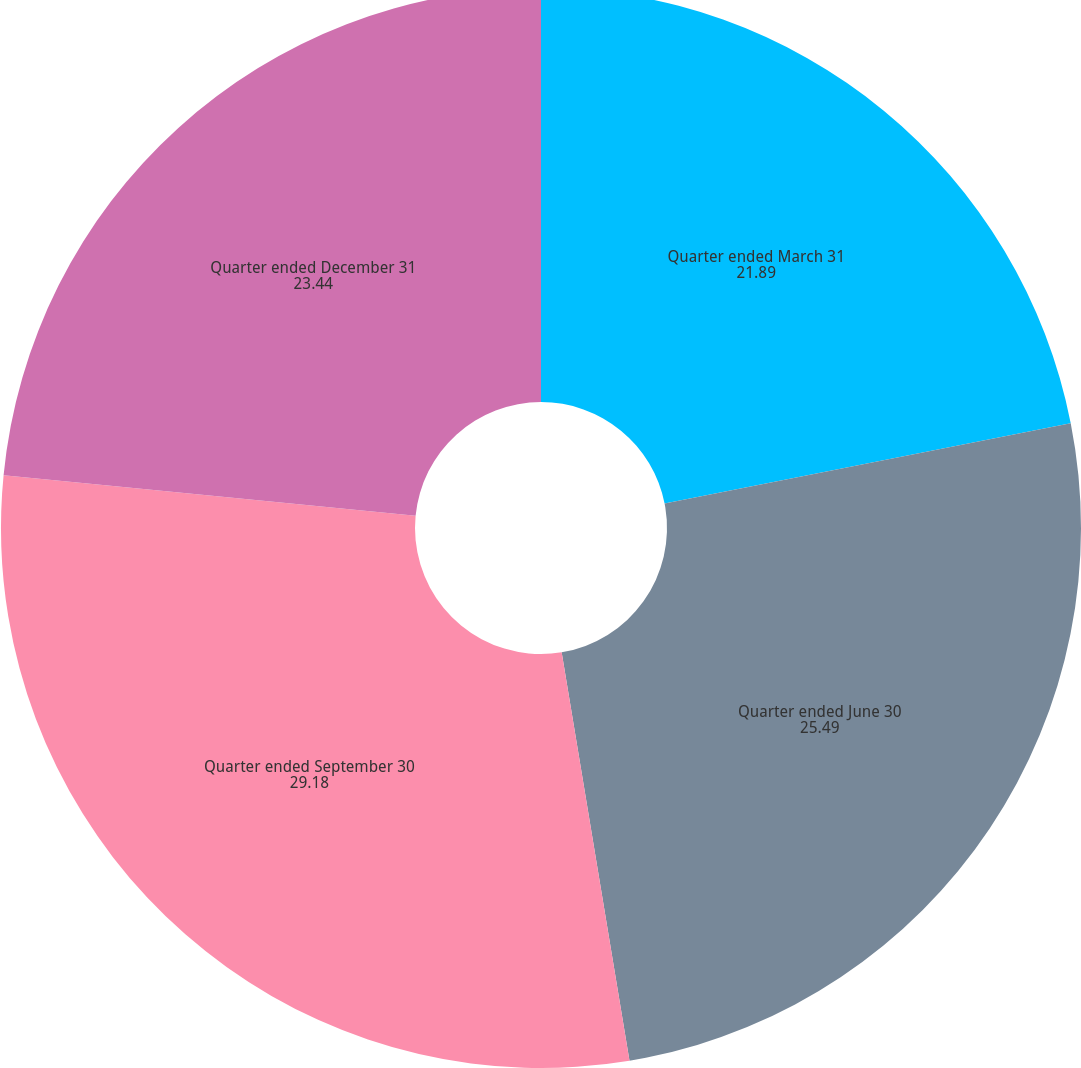Convert chart to OTSL. <chart><loc_0><loc_0><loc_500><loc_500><pie_chart><fcel>Quarter ended March 31<fcel>Quarter ended June 30<fcel>Quarter ended September 30<fcel>Quarter ended December 31<nl><fcel>21.89%<fcel>25.49%<fcel>29.18%<fcel>23.44%<nl></chart> 